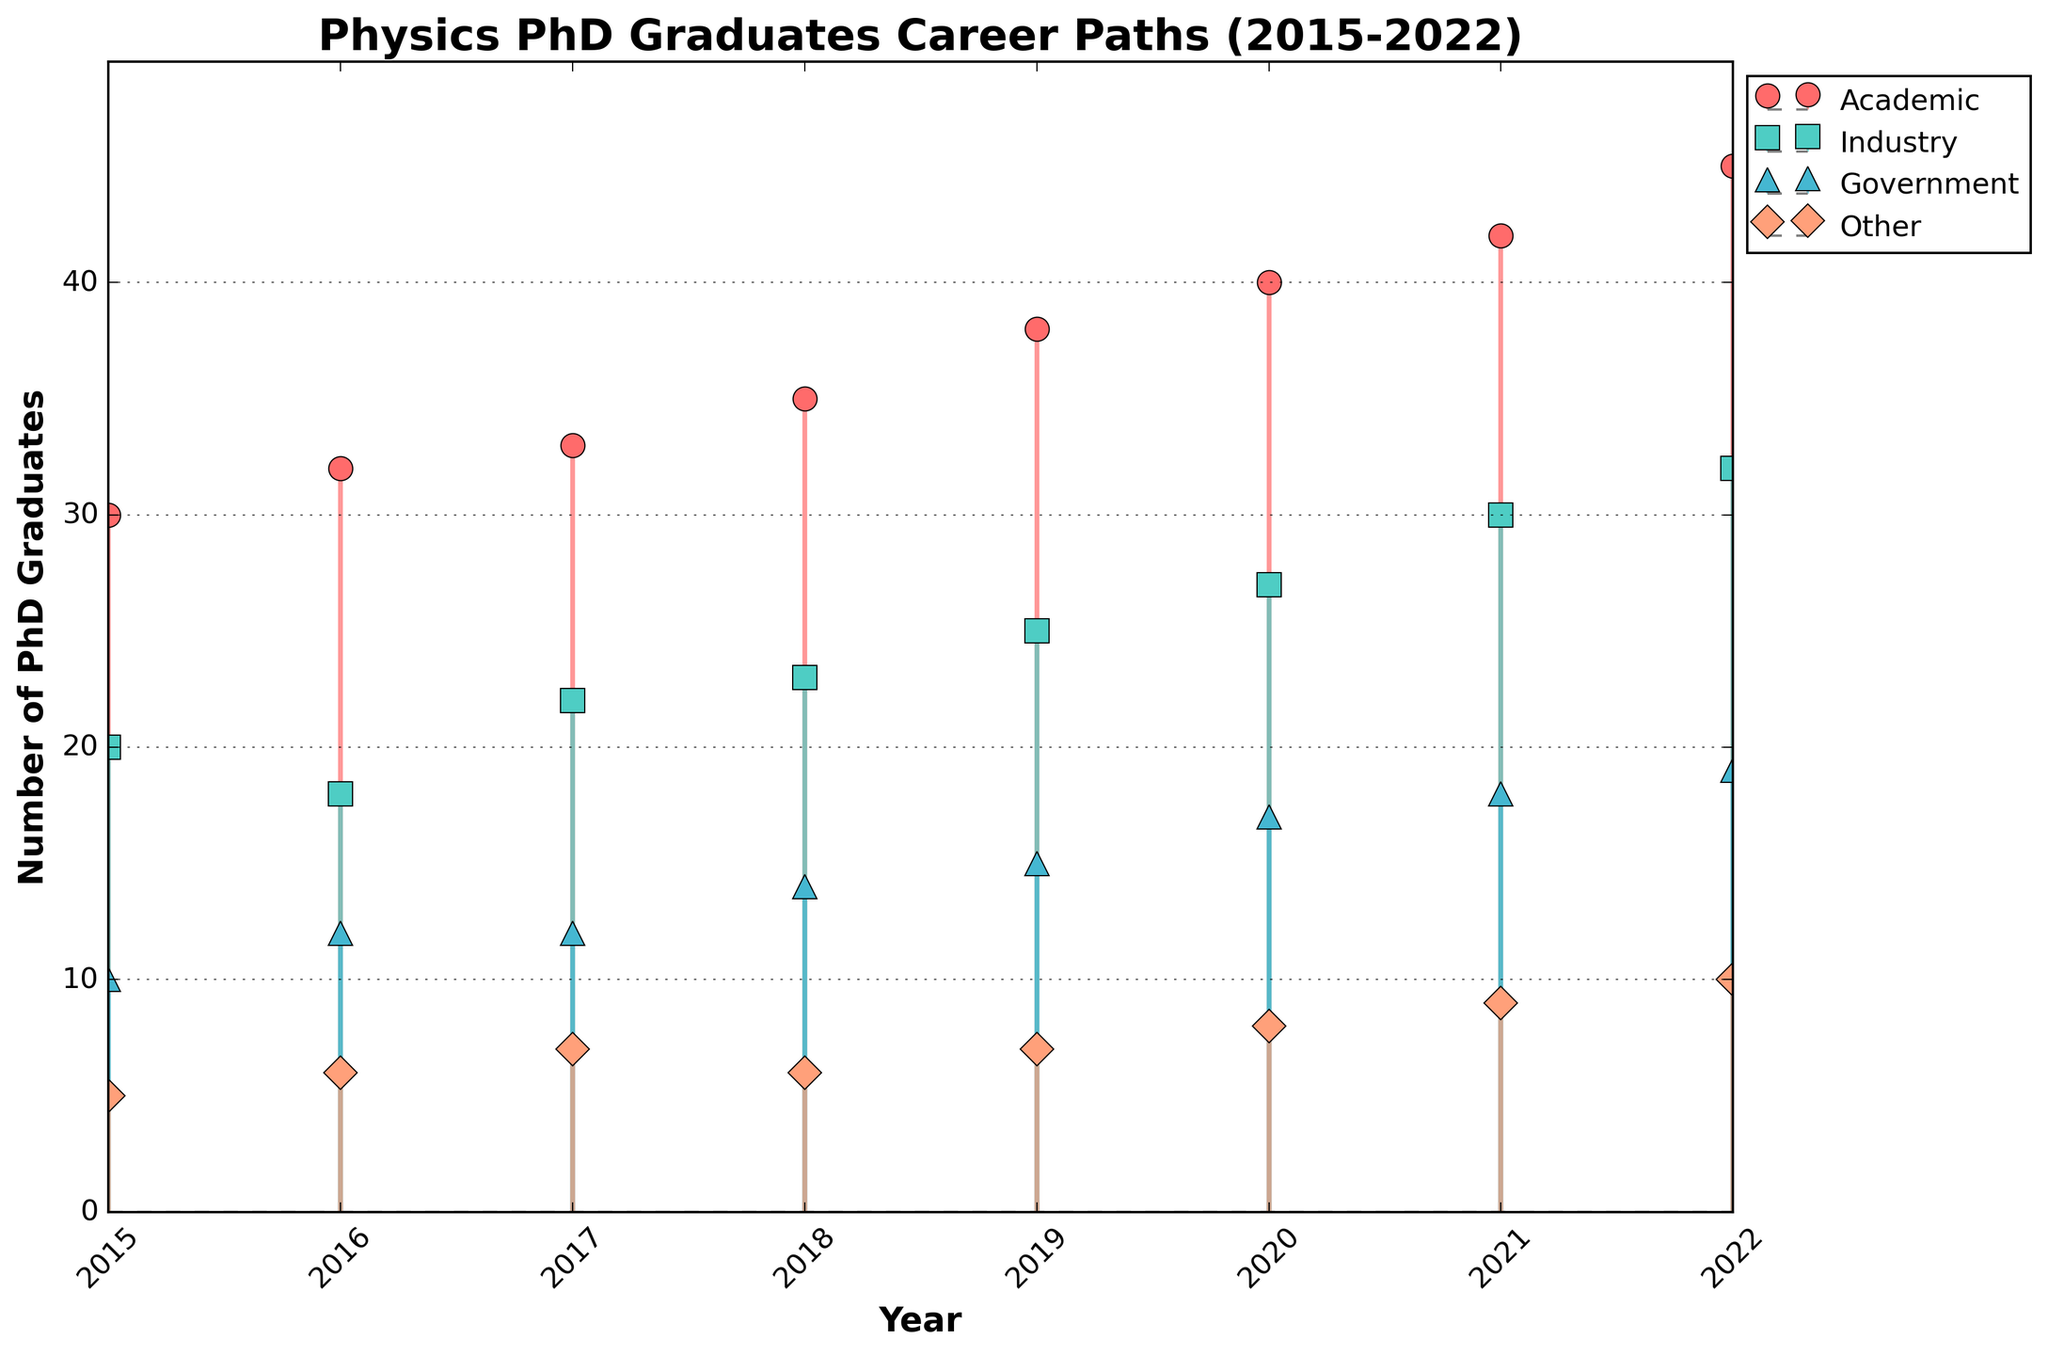What's the title of the figure? The title is located at the top of the figure and summarizes the main topic it presents.
Answer: Physics PhD Graduates Career Paths (2015-2022) How many categories of career paths are shown in the figure? The number of categories can be determined by identifying the distinct markers and colors used in the plot.
Answer: 4 Which career path had the highest number of graduates in 2022? Locate the year 2022 on the x-axis, then identify the career path with the highest stem value.
Answer: Academic What is the difference between the number of graduates in 'Academic' in 2015 and 2022? Locate the 'Academic' values for 2015 and 2022 on the y-axis, then subtract the 2015 value from the 2022 value.
Answer: 15 What trend can be observed in the 'Government' career path between 2015 and 2022? Observe the stem heights for the 'Government' category across the years 2015 to 2022 to determine if they are increasing, decreasing, or fluctuating.
Answer: Increasing By how much did the number of graduates in Industry increase from 2017 to 2021? Identify the number of 'Industry' graduates for the years 2017 and 2021, then calculate the difference by subtracting the 2017 value from the 2021 value.
Answer: 8 Is the number of PhD graduates in the 'Other' category showing an upward or downward trend? Examine the stem heights for the 'Other' category from 2015 to 2022 to identify a general increase or decrease.
Answer: Upward Which year had the lowest number of PhD graduates entering 'Industry'? Locate the lowest stem value in the 'Industry' category by examining the y-axis values across the years.
Answer: 2016 In which year did the 'Academic' career path surpass 40 graduates for the first time? Look for the first instance where the 'Academic' stem height reaches or exceeds 40.
Answer: 2020 By how much did the total number of graduates in all categories increase from 2015 to 2022? Sum the number of graduates across all categories for 2015 and 2022, then subtract the 2015 total from the 2022 total. Detailed calculation: For 2015, the sum is 30+20+10+5=65. For 2022, the sum is 45+32+19+10=106. The difference is 106-65=41.
Answer: 41 